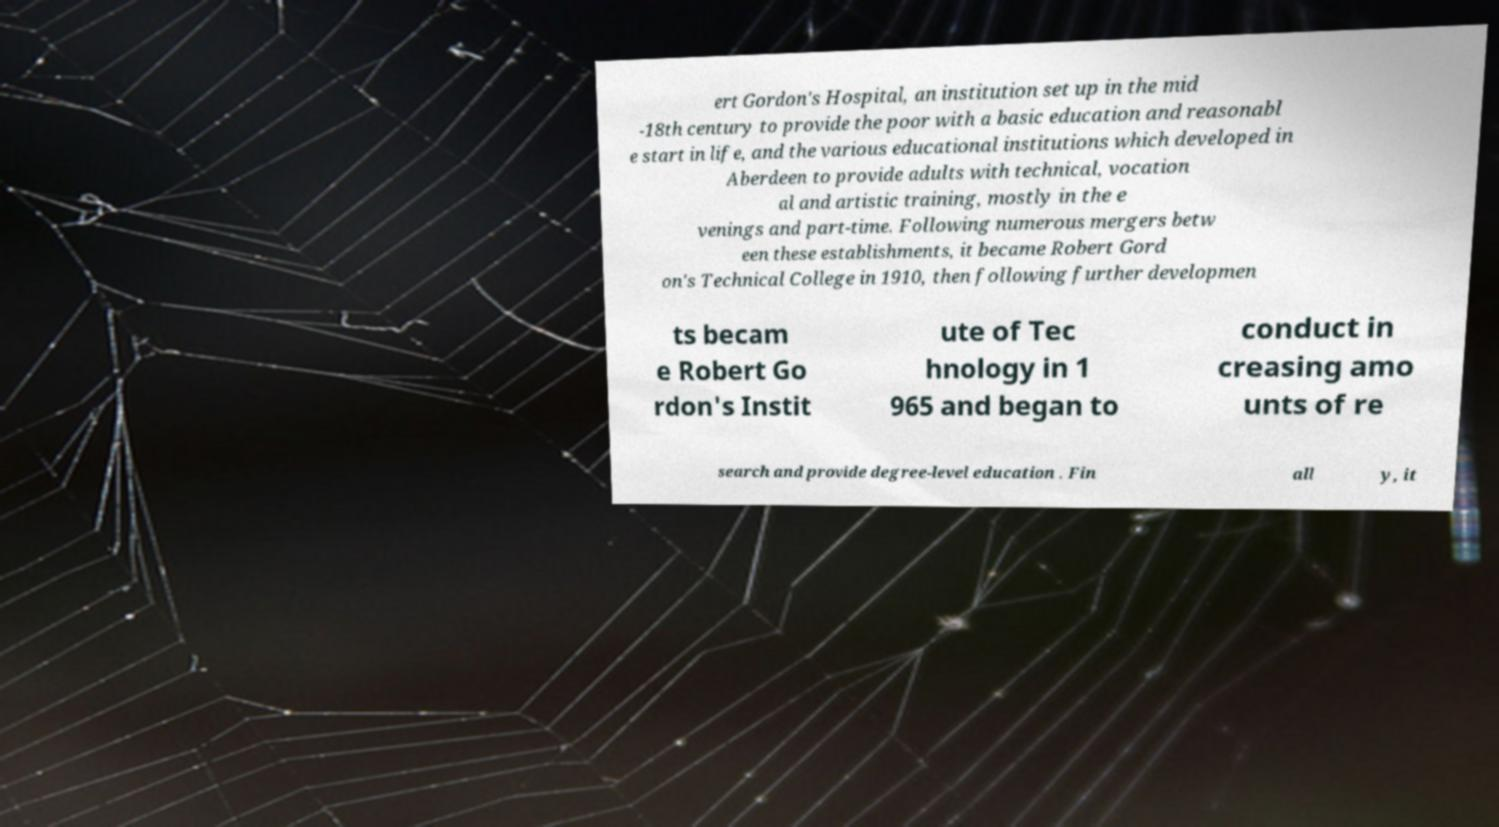Could you assist in decoding the text presented in this image and type it out clearly? ert Gordon's Hospital, an institution set up in the mid -18th century to provide the poor with a basic education and reasonabl e start in life, and the various educational institutions which developed in Aberdeen to provide adults with technical, vocation al and artistic training, mostly in the e venings and part-time. Following numerous mergers betw een these establishments, it became Robert Gord on's Technical College in 1910, then following further developmen ts becam e Robert Go rdon's Instit ute of Tec hnology in 1 965 and began to conduct in creasing amo unts of re search and provide degree-level education . Fin all y, it 